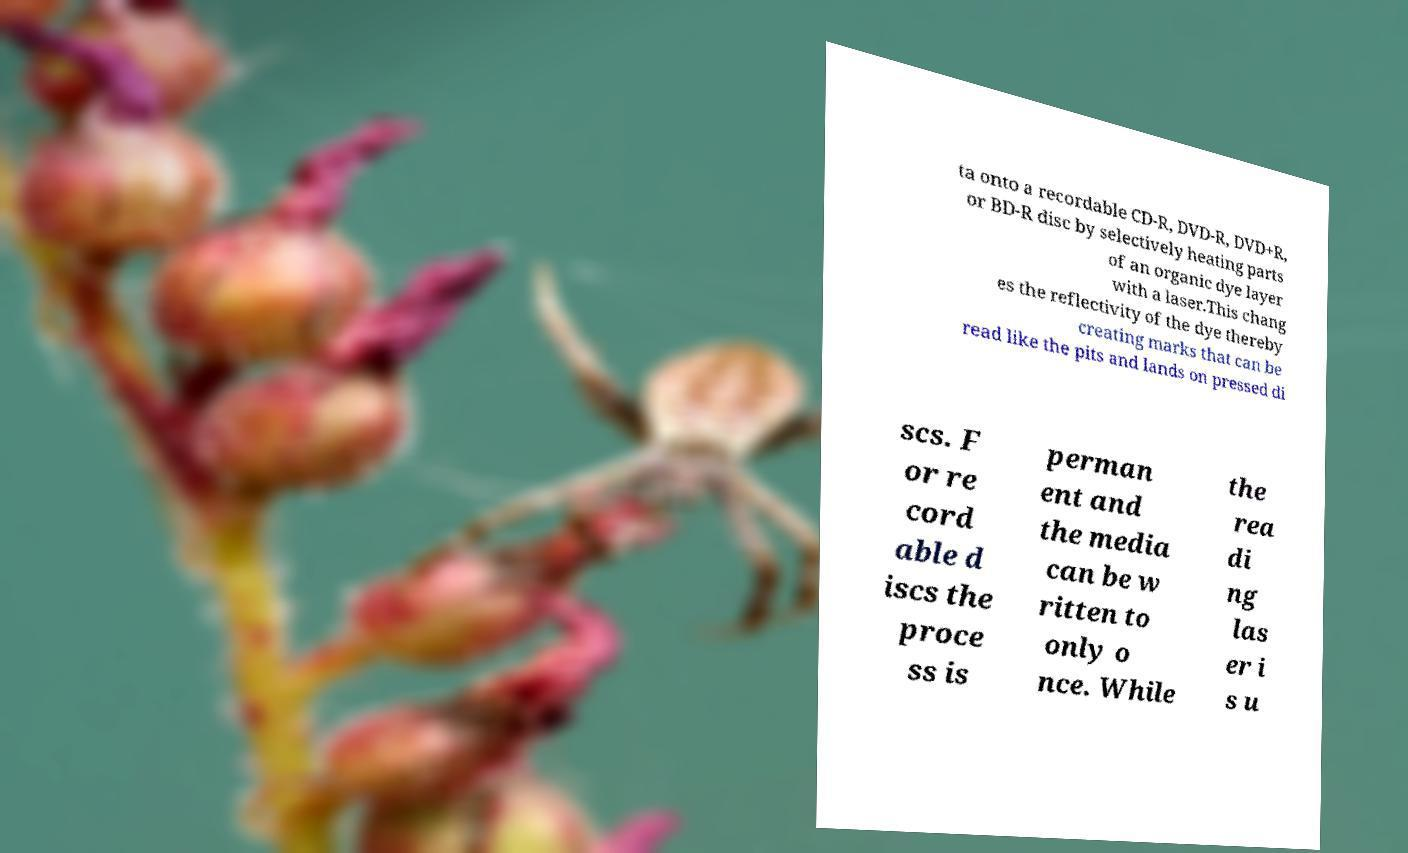For documentation purposes, I need the text within this image transcribed. Could you provide that? ta onto a recordable CD-R, DVD-R, DVD+R, or BD-R disc by selectively heating parts of an organic dye layer with a laser.This chang es the reflectivity of the dye thereby creating marks that can be read like the pits and lands on pressed di scs. F or re cord able d iscs the proce ss is perman ent and the media can be w ritten to only o nce. While the rea di ng las er i s u 